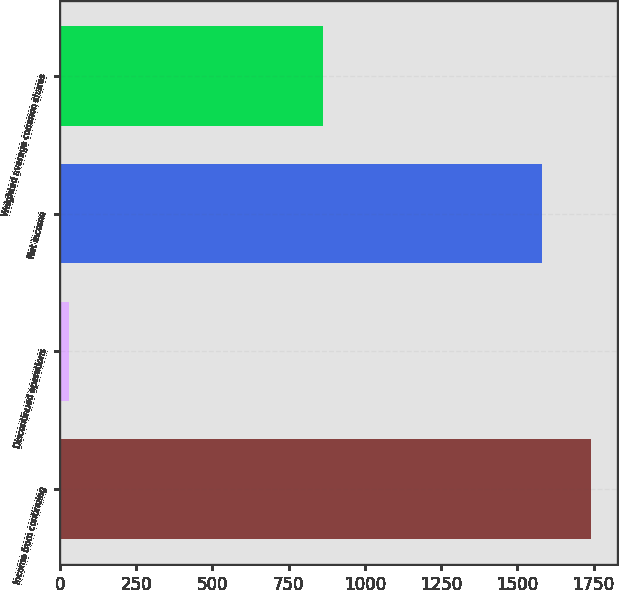Convert chart. <chart><loc_0><loc_0><loc_500><loc_500><bar_chart><fcel>Income from continuing<fcel>Discontinued operations<fcel>Net income<fcel>Weighted average common shares<nl><fcel>1740.2<fcel>31<fcel>1582<fcel>864.2<nl></chart> 